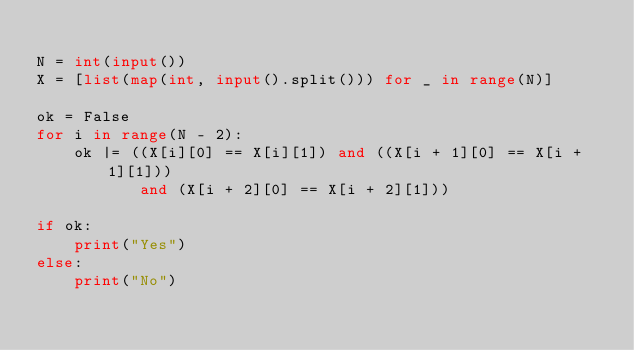<code> <loc_0><loc_0><loc_500><loc_500><_Python_>
N = int(input())
X = [list(map(int, input().split())) for _ in range(N)]

ok = False
for i in range(N - 2):
    ok |= ((X[i][0] == X[i][1]) and ((X[i + 1][0] == X[i + 1][1]))
           and (X[i + 2][0] == X[i + 2][1]))

if ok:
    print("Yes")
else:
    print("No")
</code> 